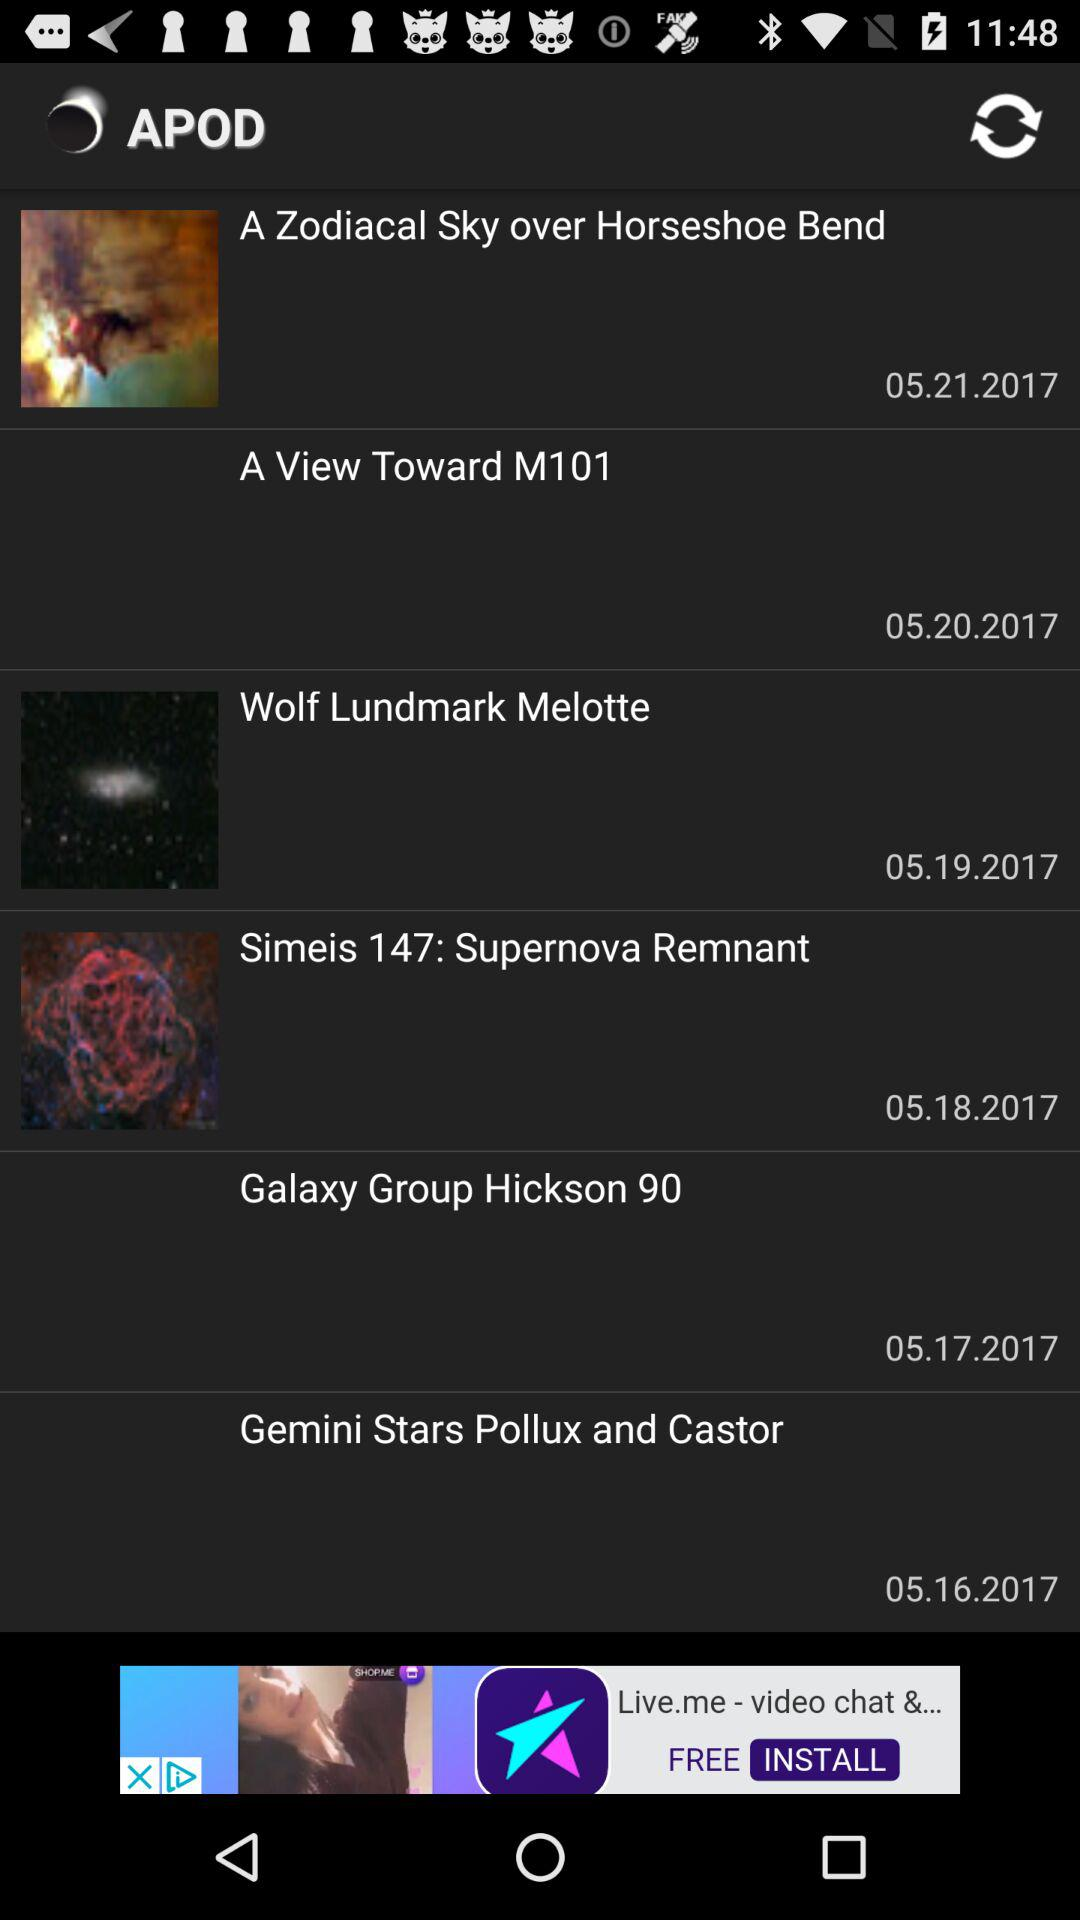What is the name of the application? The name of the application is "APOD". 